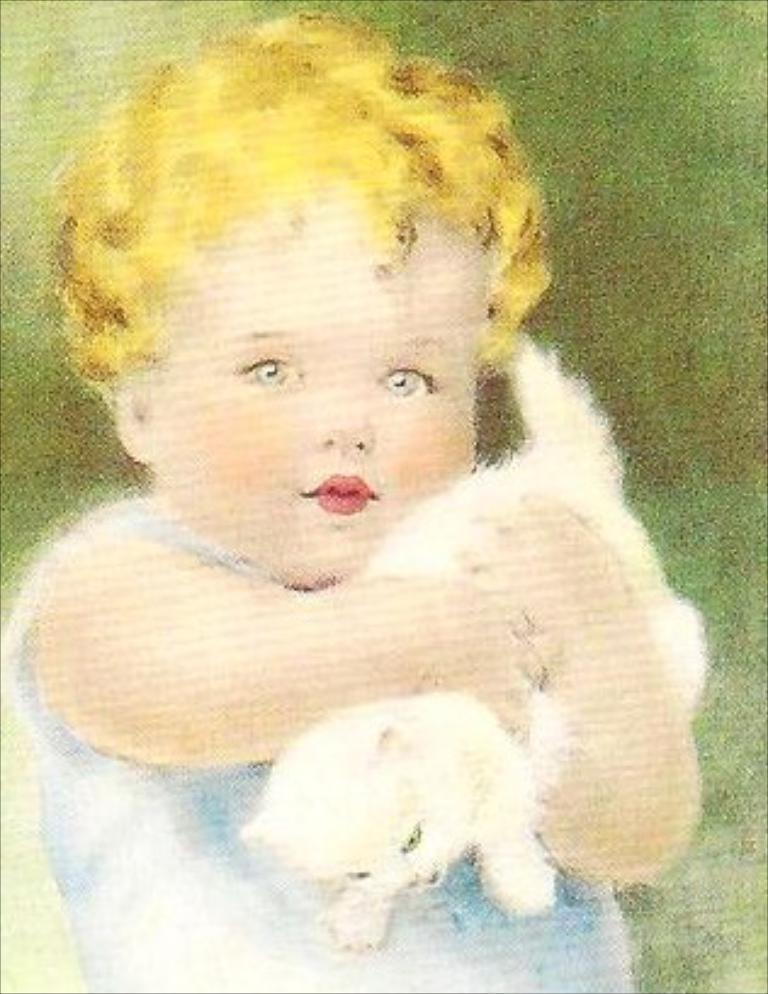Could you give a brief overview of what you see in this image? In this image we can see a painting of a girl holding a cat in her hand. 